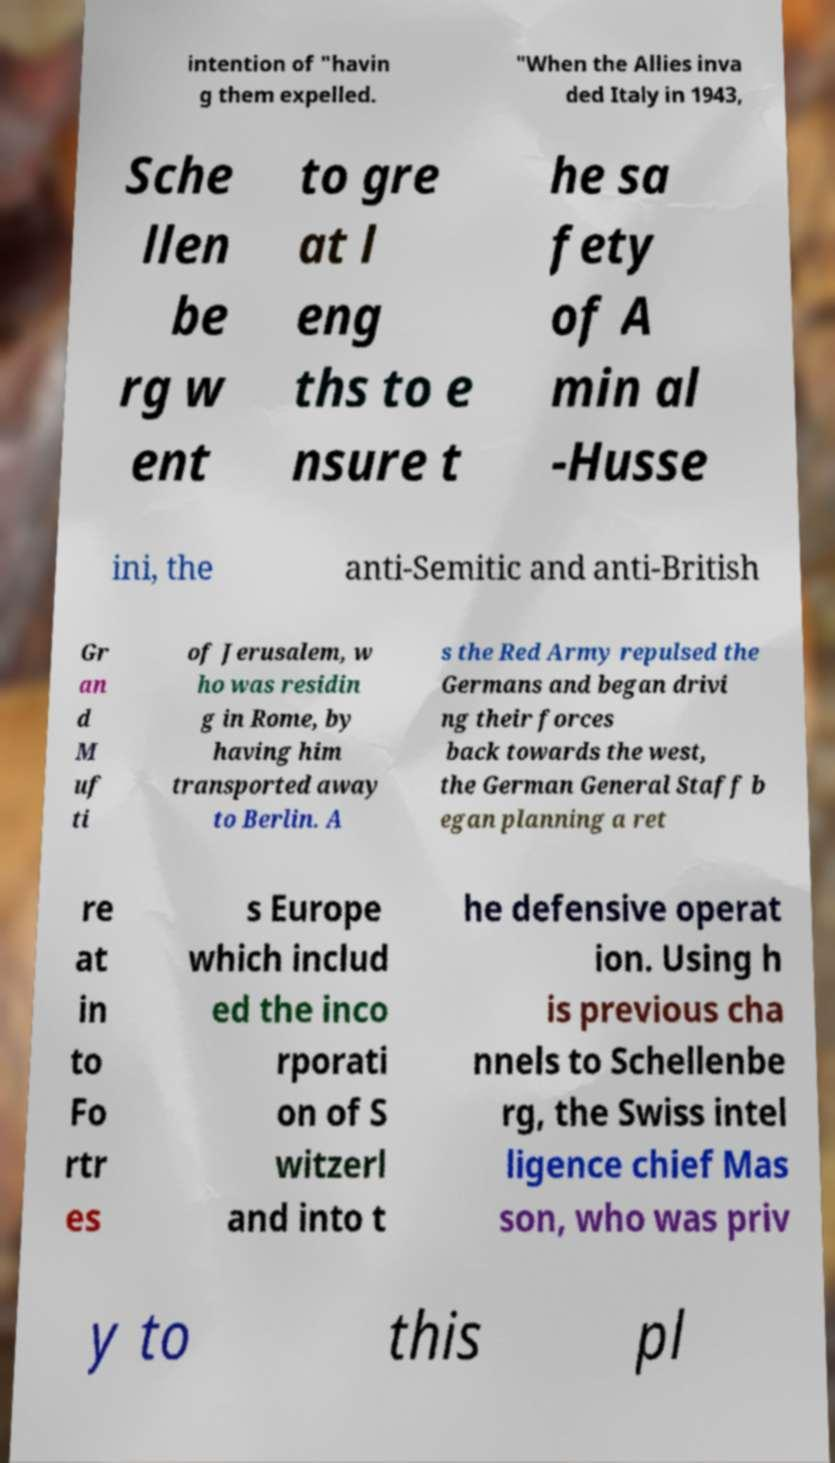Can you read and provide the text displayed in the image?This photo seems to have some interesting text. Can you extract and type it out for me? intention of "havin g them expelled. "When the Allies inva ded Italy in 1943, Sche llen be rg w ent to gre at l eng ths to e nsure t he sa fety of A min al -Husse ini, the anti-Semitic and anti-British Gr an d M uf ti of Jerusalem, w ho was residin g in Rome, by having him transported away to Berlin. A s the Red Army repulsed the Germans and began drivi ng their forces back towards the west, the German General Staff b egan planning a ret re at in to Fo rtr es s Europe which includ ed the inco rporati on of S witzerl and into t he defensive operat ion. Using h is previous cha nnels to Schellenbe rg, the Swiss intel ligence chief Mas son, who was priv y to this pl 